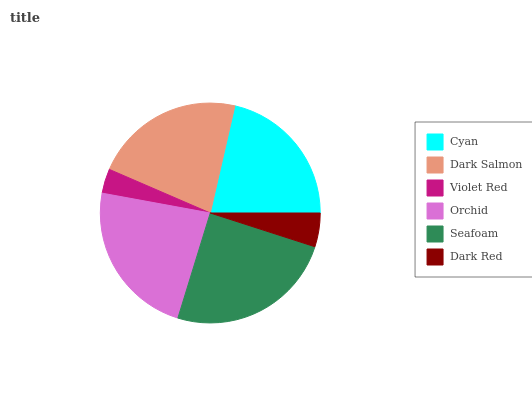Is Violet Red the minimum?
Answer yes or no. Yes. Is Seafoam the maximum?
Answer yes or no. Yes. Is Dark Salmon the minimum?
Answer yes or no. No. Is Dark Salmon the maximum?
Answer yes or no. No. Is Dark Salmon greater than Cyan?
Answer yes or no. Yes. Is Cyan less than Dark Salmon?
Answer yes or no. Yes. Is Cyan greater than Dark Salmon?
Answer yes or no. No. Is Dark Salmon less than Cyan?
Answer yes or no. No. Is Dark Salmon the high median?
Answer yes or no. Yes. Is Cyan the low median?
Answer yes or no. Yes. Is Cyan the high median?
Answer yes or no. No. Is Dark Red the low median?
Answer yes or no. No. 